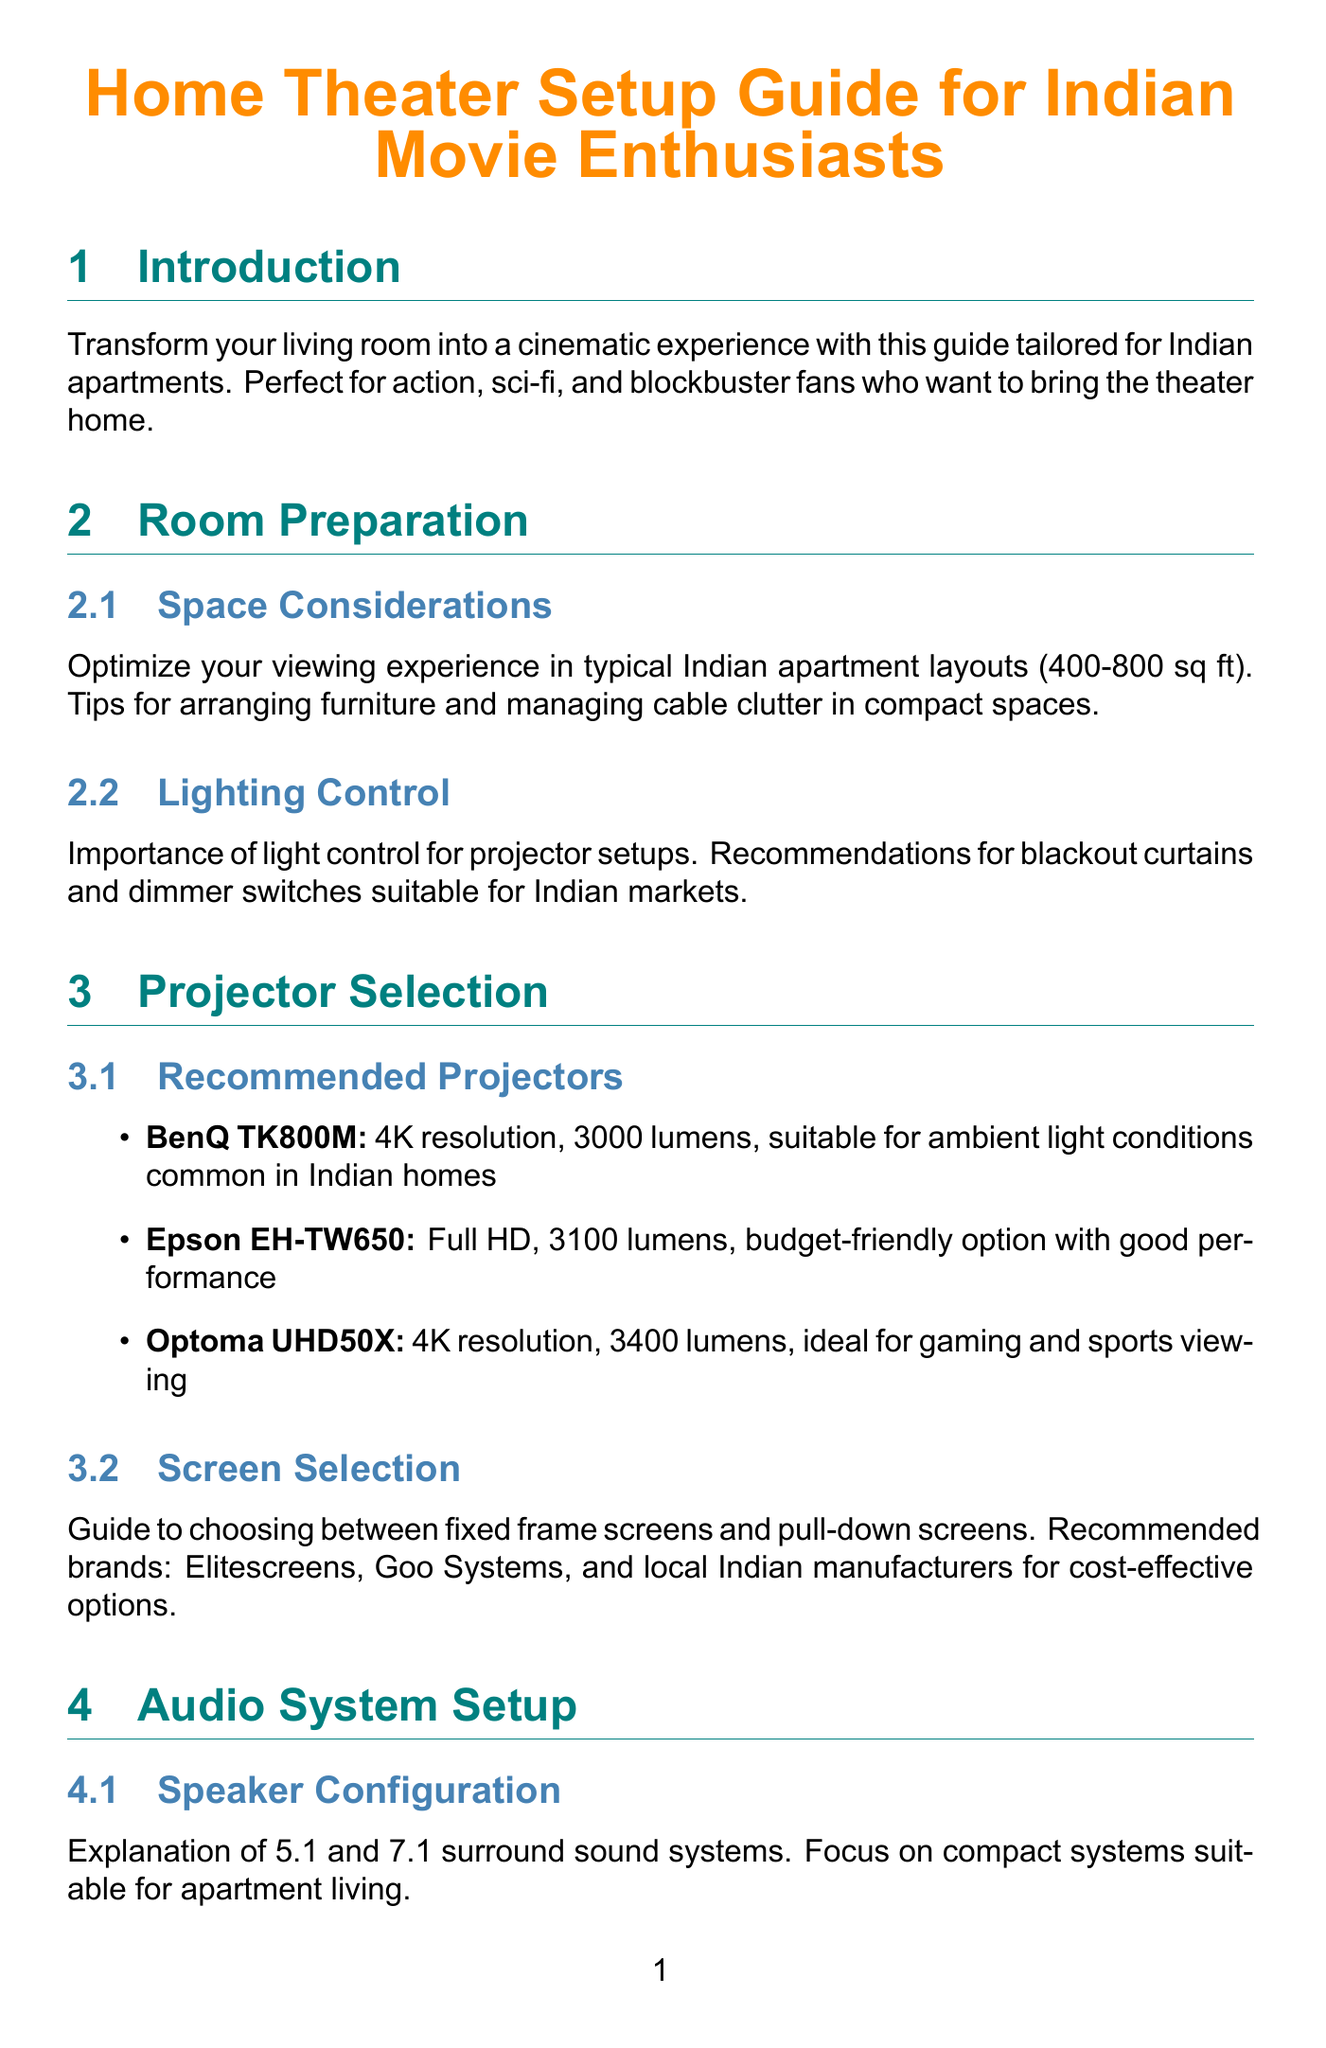What is the title of the manual? The title of the manual is the first line at the top, which defines its focus and audience.
Answer: Home Theater Setup Guide for Indian Movie Enthusiasts What is the recommended projector with 4K resolution and 3400 lumens? The document lists projectors along with their specifications, including resolution and lumens.
Answer: Optoma UHD50X What is the typical size range for Indian apartments mentioned? The document discusses room preparation and provides space considerations specific to Indian homes.
Answer: 400-800 sq ft What audio system is described as budget-friendly and ideal for small apartments? The document includes a section on recommended audio systems, highlighting their features and suitability for different spaces.
Answer: Logitech Z906 What type of speaker system is explained in the manual? The manual provides configurations that are commonly used in home theater setups.
Answer: 5.1 and 7.1 surround sound systems Which streaming device is mentioned for setting up streaming in the document? The guide lists specific streaming devices that can be used to access popular services in India.
Answer: Amazon Fire TV Stick 4K What is one of the recommended brands for projector screens? The manual provides guidance on screen selection and suggests brands that cater to consumers in India.
Answer: Elitescreens What is a common issue in Indian apartments addressed in the troubleshooting section? The document identifies specific challenges that may arise during the setup and usage of home theater systems.
Answer: Power fluctuations What is a maintenance tip given for projectors in Indian cities? The guide includes advice on how to care for equipment, considering environmental factors that affect performance.
Answer: Cleaning filters 